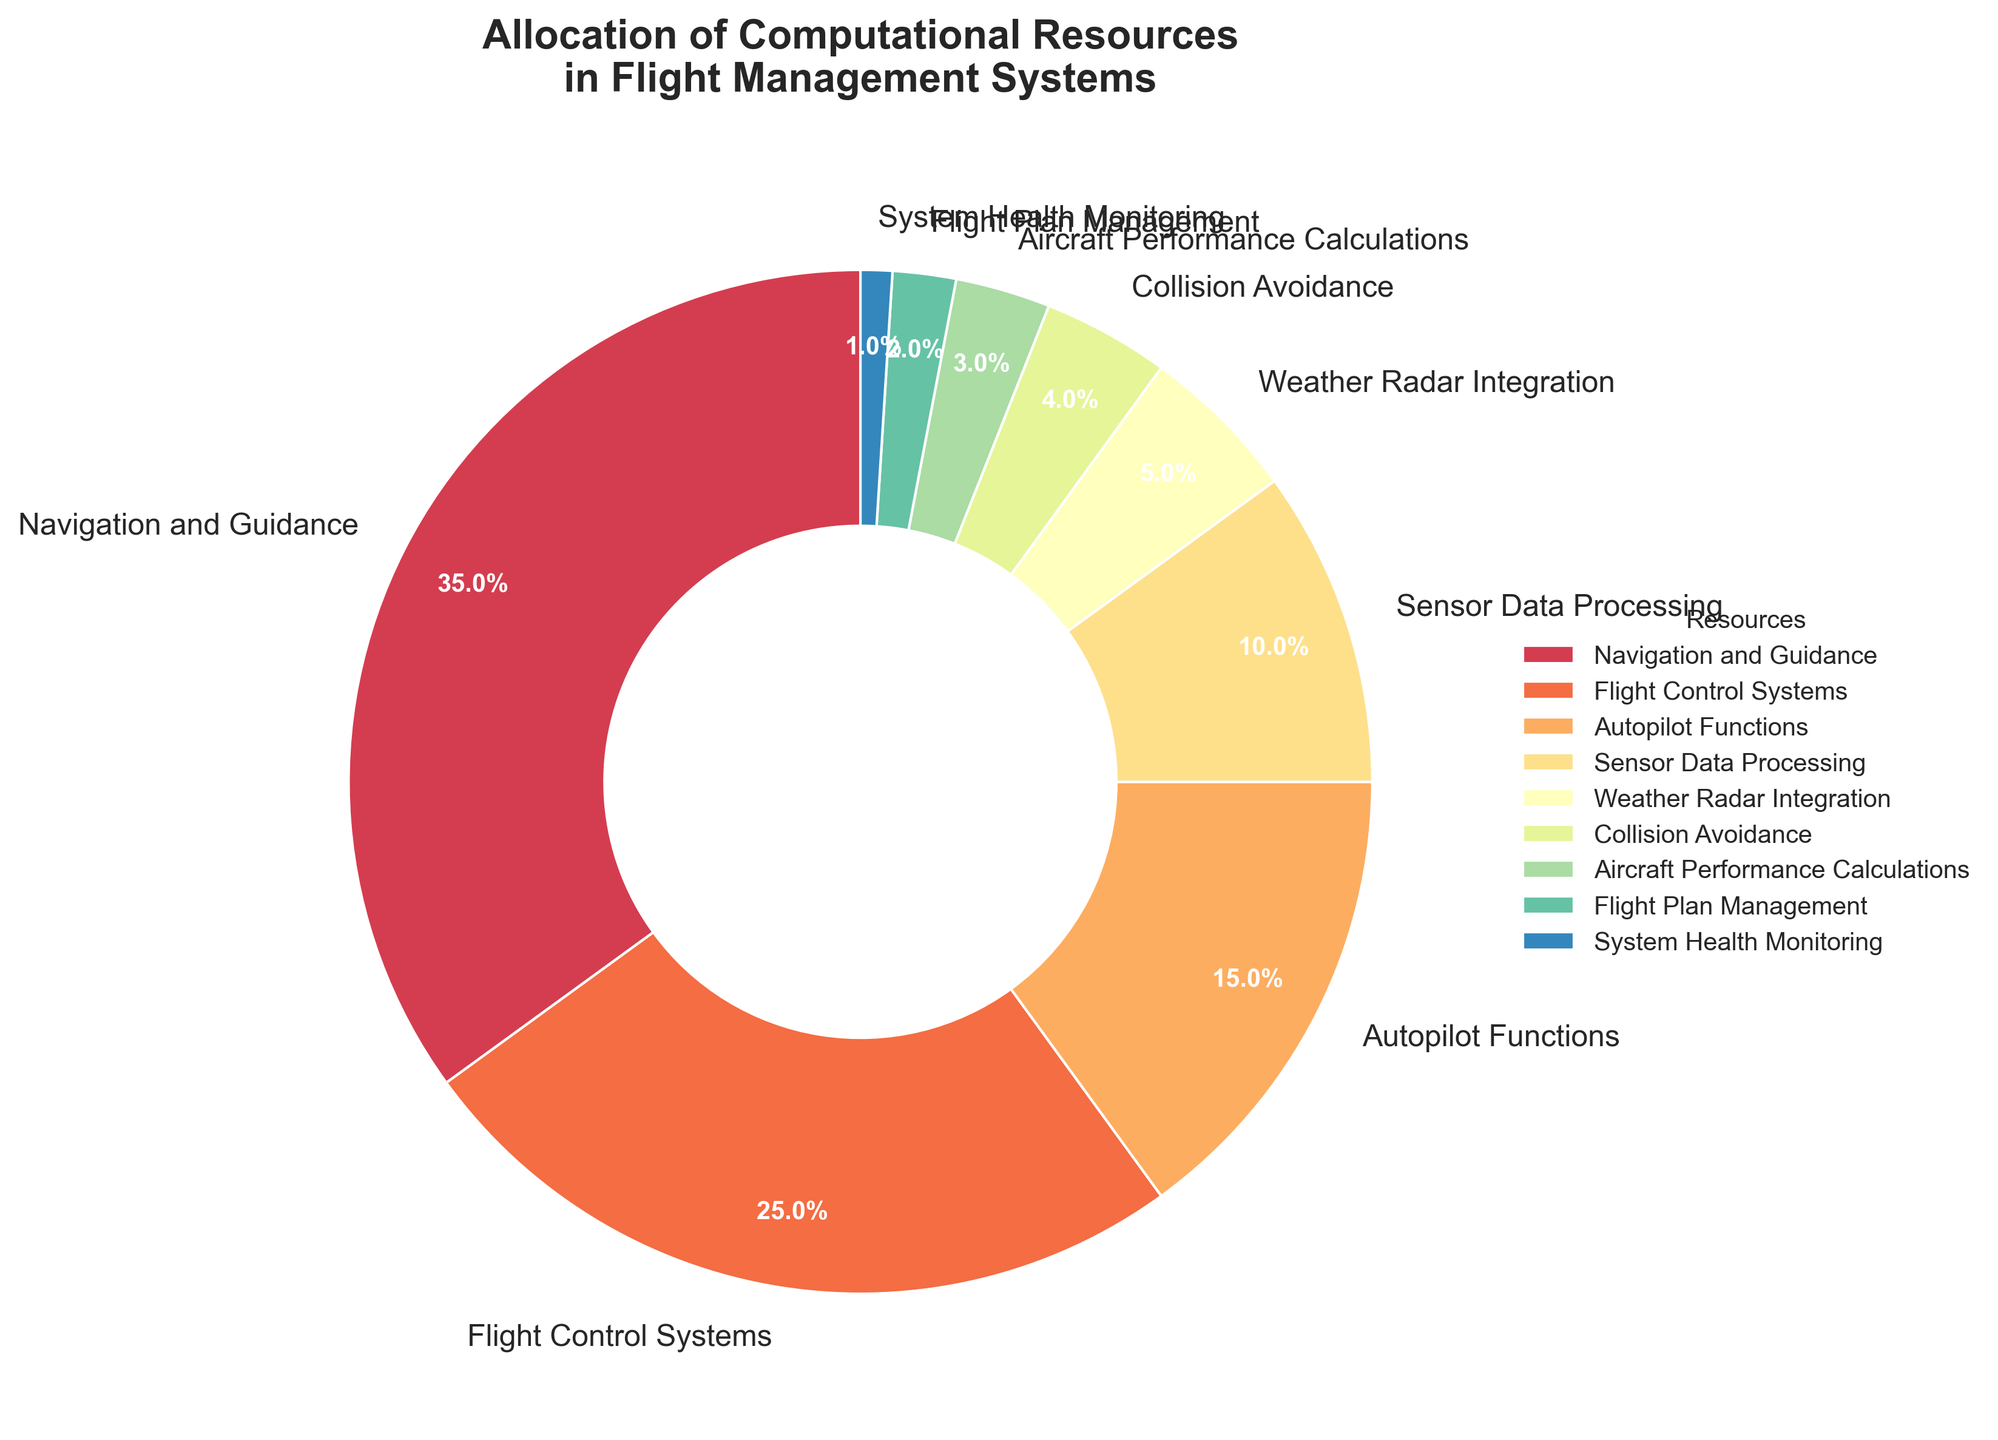Which resource category uses the highest percentage of computational resources? By looking at the pie chart, the largest segment represents the highest percentage. The segment labeled "Navigation and Guidance" is the largest with 35%.
Answer: Navigation and Guidance What is the combined percentage allocation of Flight Control Systems and Autopilot Functions? The percentage for Flight Control Systems is 25%, and for Autopilot Functions, it is 15%. Adding these together: 25% + 15% = 40%.
Answer: 40% Which resources collectively consume less than 10% of the computational resources? Observing the sectors with less than 10% allocation: Weather Radar Integration (5%), Collision Avoidance (4%), Aircraft Performance Calculations (3%), Flight Plan Management (2%), and System Health Monitoring (1%). Summing these, 5% + 4% + 3% + 2% + 1% = 15%, and all individually are <10%.
Answer: Weather Radar Integration, Collision Avoidance, Aircraft Performance Calculations, Flight Plan Management, System Health Monitoring Is the percentage allocation for Sensor Data Processing greater than, less than, or equal to the combined allocation for Flight Plan Management and System Health Monitoring? The allocation for Sensor Data Processing is 10%. The combined allocation for Flight Plan Management and System Health Monitoring is 2% + 1% = 3%. 10% is greater than 3%.
Answer: Greater than What percentage difference exists between the resources allocated to Navigation and Guidance and Flight Control Systems? Navigation and Guidance is allocated 35%, and Flight Control Systems are allocated 25%. The difference is 35% - 25% = 10%.
Answer: 10% Which resource category has the smallest allocation of computational resources? The smallest segment in the pie chart is labeled "System Health Monitoring" with 1%.
Answer: System Health Monitoring By how much does the percentage allocation for Autopilot Functions exceed that for Weather Radar Integration? Autopilot Functions is allocated 15%, and Weather Radar Integration is allocated 5%. The excess is 15% - 5% = 10%.
Answer: 10% Are the combined allocations of Flight Plan Management and System Health Monitoring greater than or less than the allocation for Collision Avoidance? Combined allocation for Flight Plan Management and System Health Monitoring is 2% + 1% = 3%. Allocation for Collision Avoidance is 4%. 3% is less than 4%.
Answer: Less than Which two resources have the closest percentage allocations? By examining the chart, Flight Control Systems (25%) and Autopilot Functions (15%) have a difference of 10%, which is the closest compared to other pairs.
Answer: Flight Control Systems and Autopilot Functions 